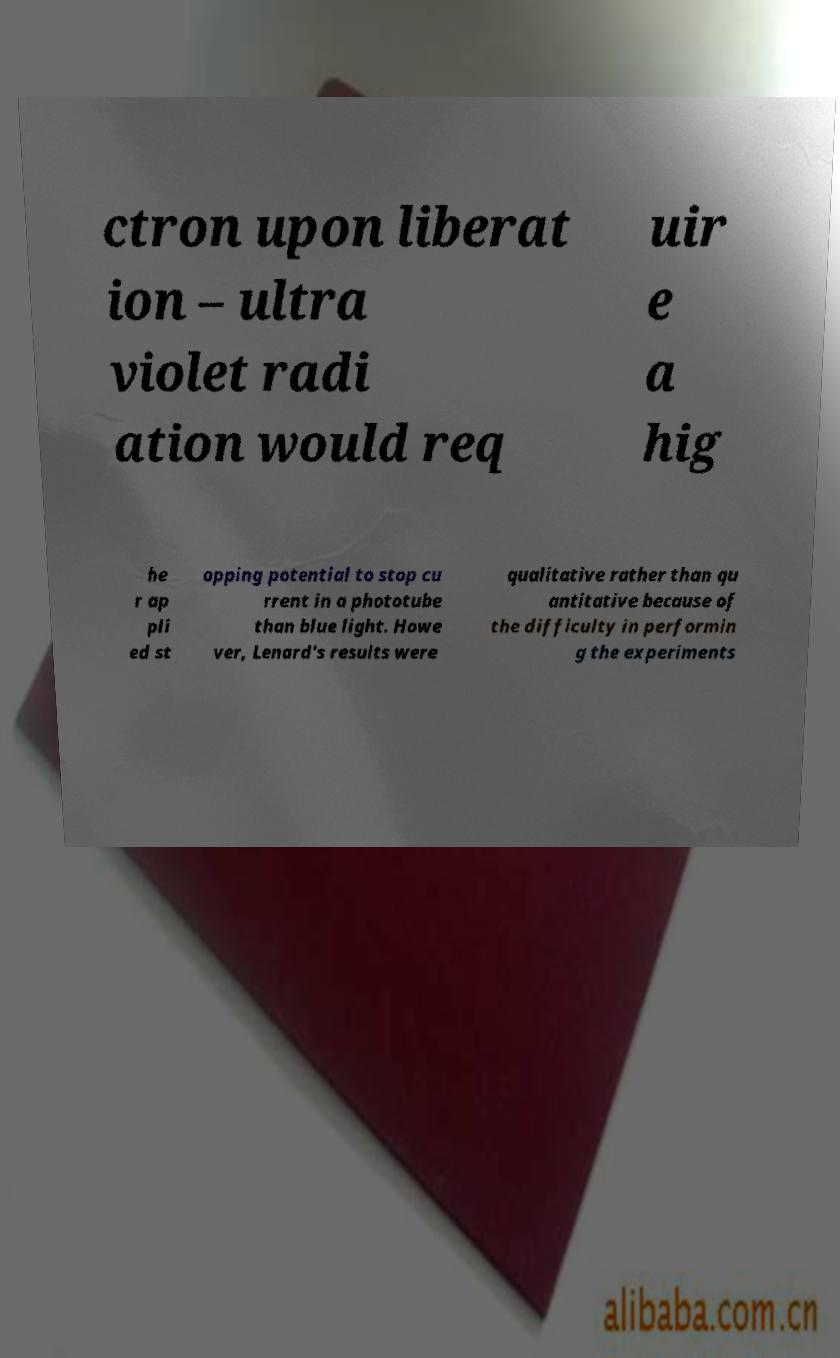What messages or text are displayed in this image? I need them in a readable, typed format. ctron upon liberat ion – ultra violet radi ation would req uir e a hig he r ap pli ed st opping potential to stop cu rrent in a phototube than blue light. Howe ver, Lenard's results were qualitative rather than qu antitative because of the difficulty in performin g the experiments 